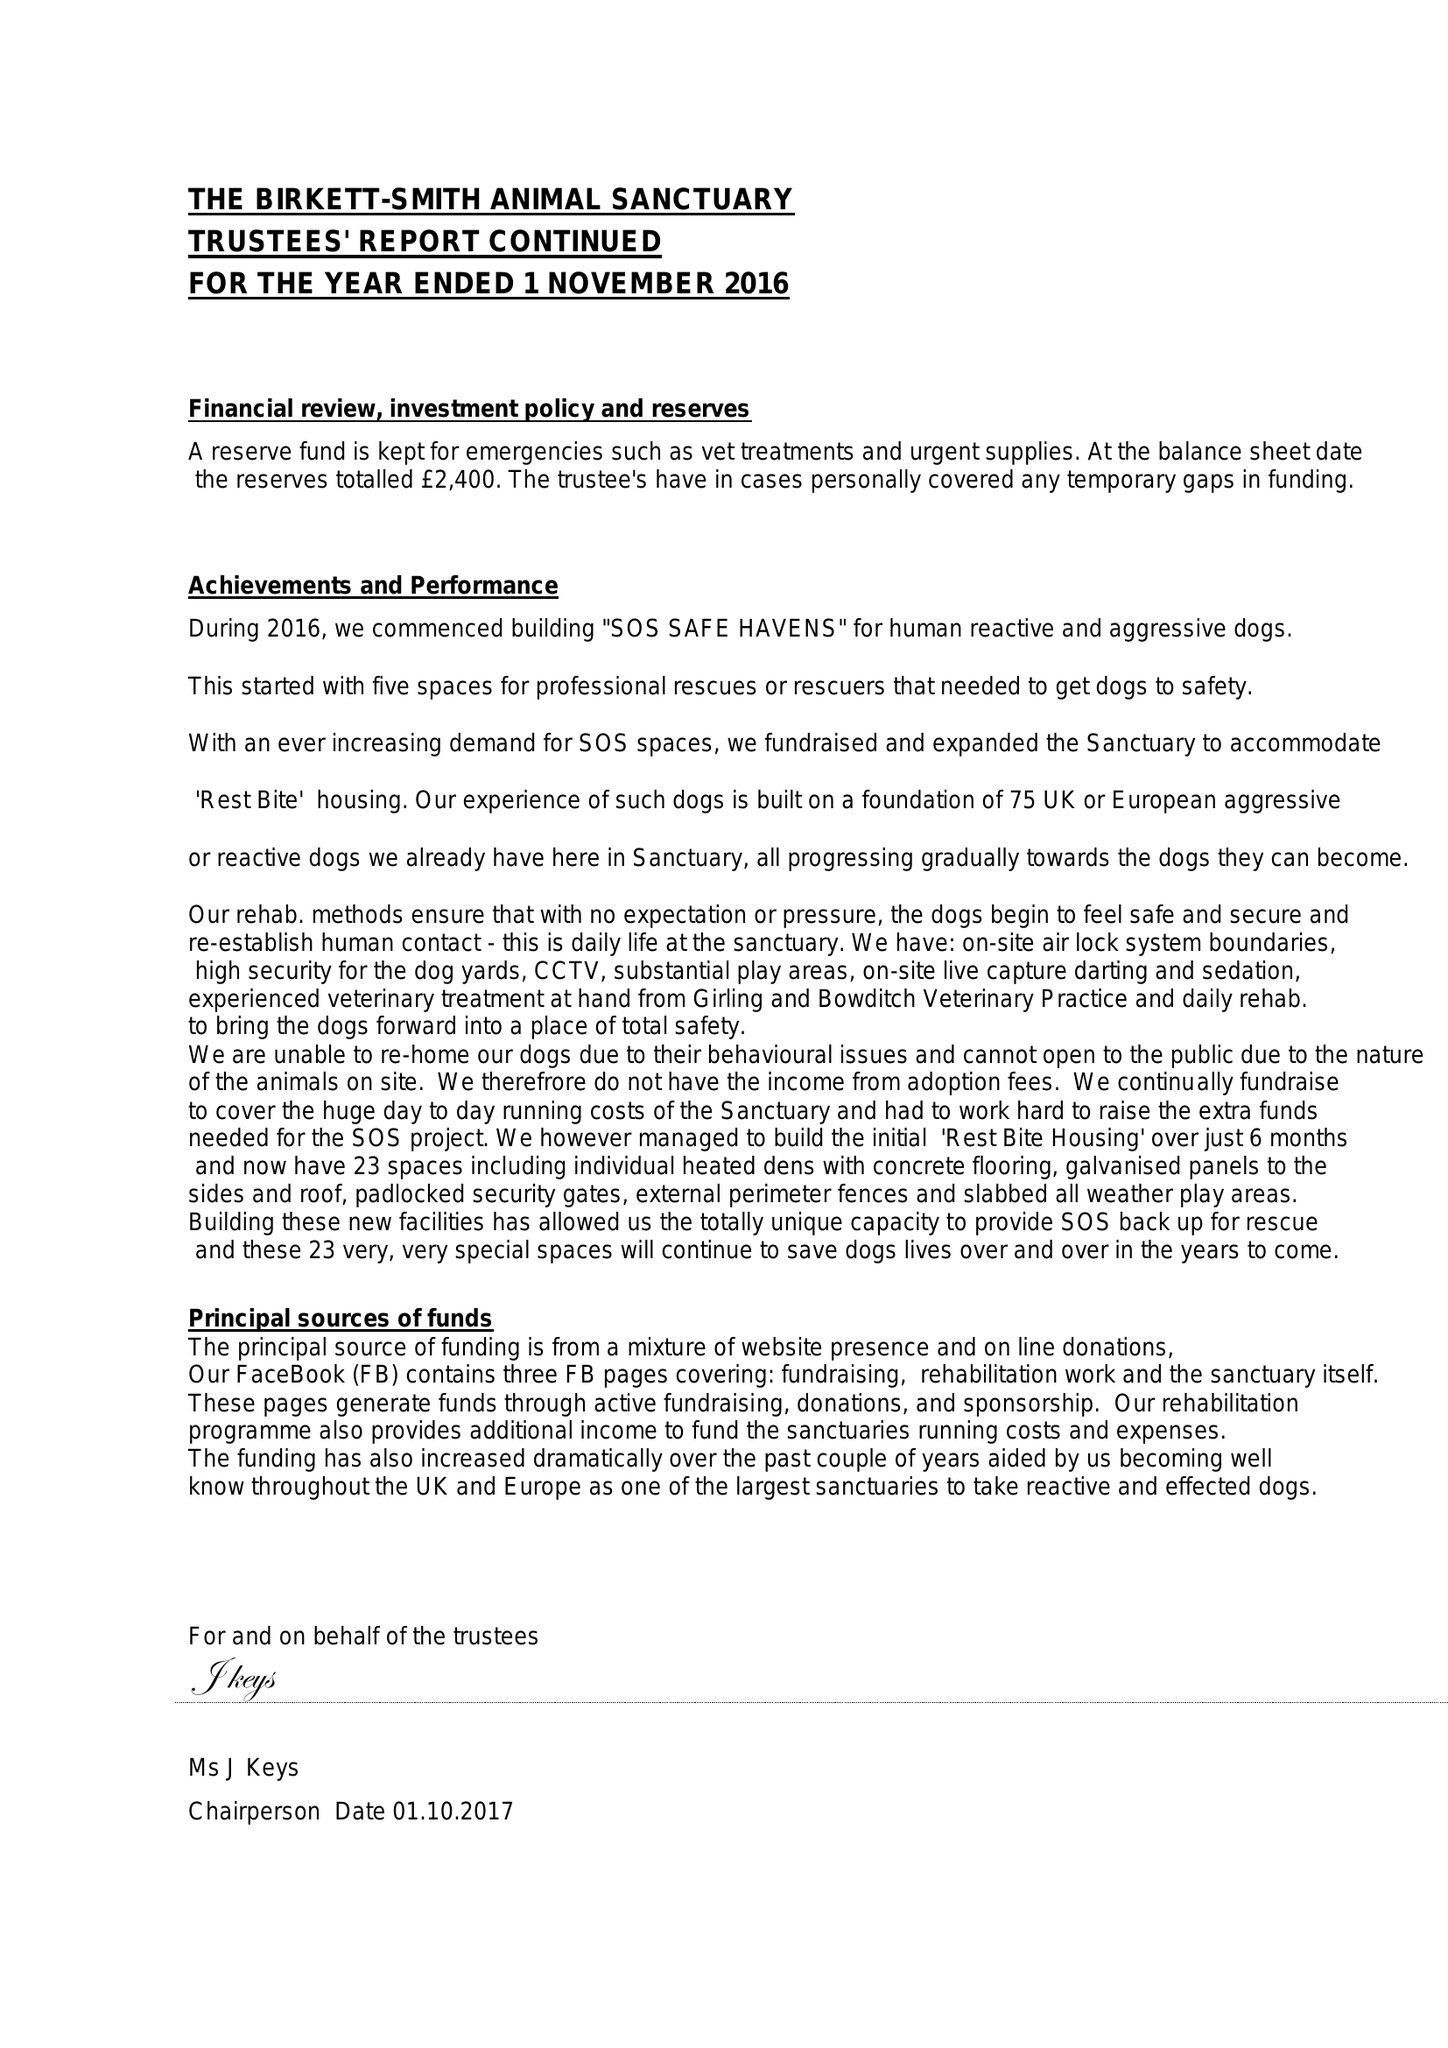What is the value for the address__post_town?
Answer the question using a single word or phrase. BRIDPORT 